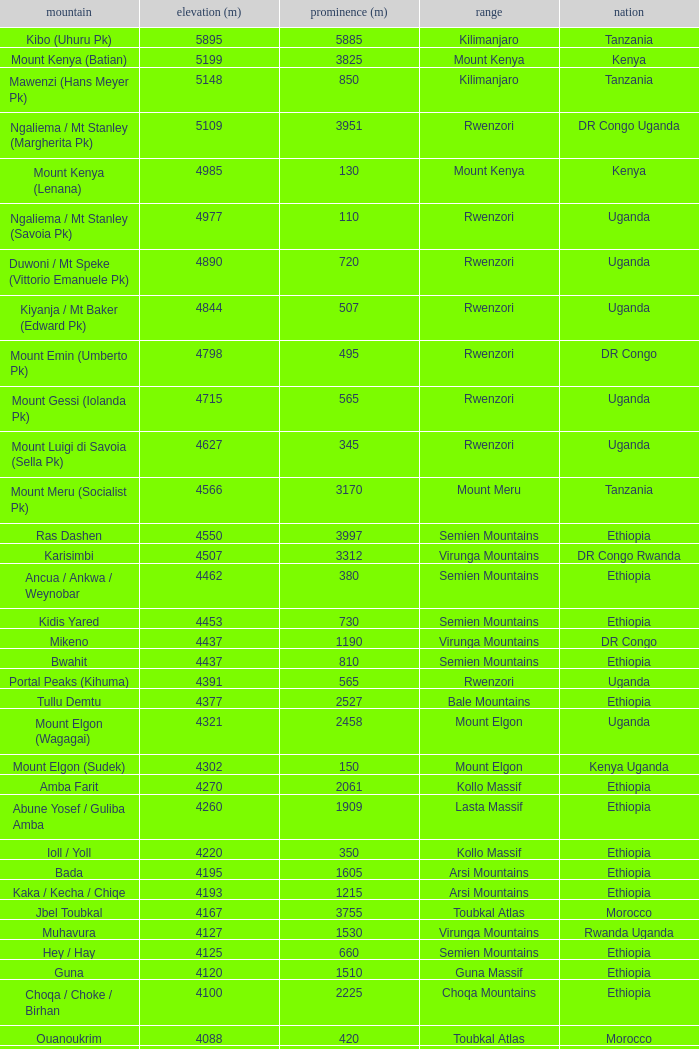Which Country has a Prominence (m) smaller than 1540, and a Height (m) smaller than 3530, and a Range of virunga mountains, and a Mountain of nyiragongo? DR Congo. 